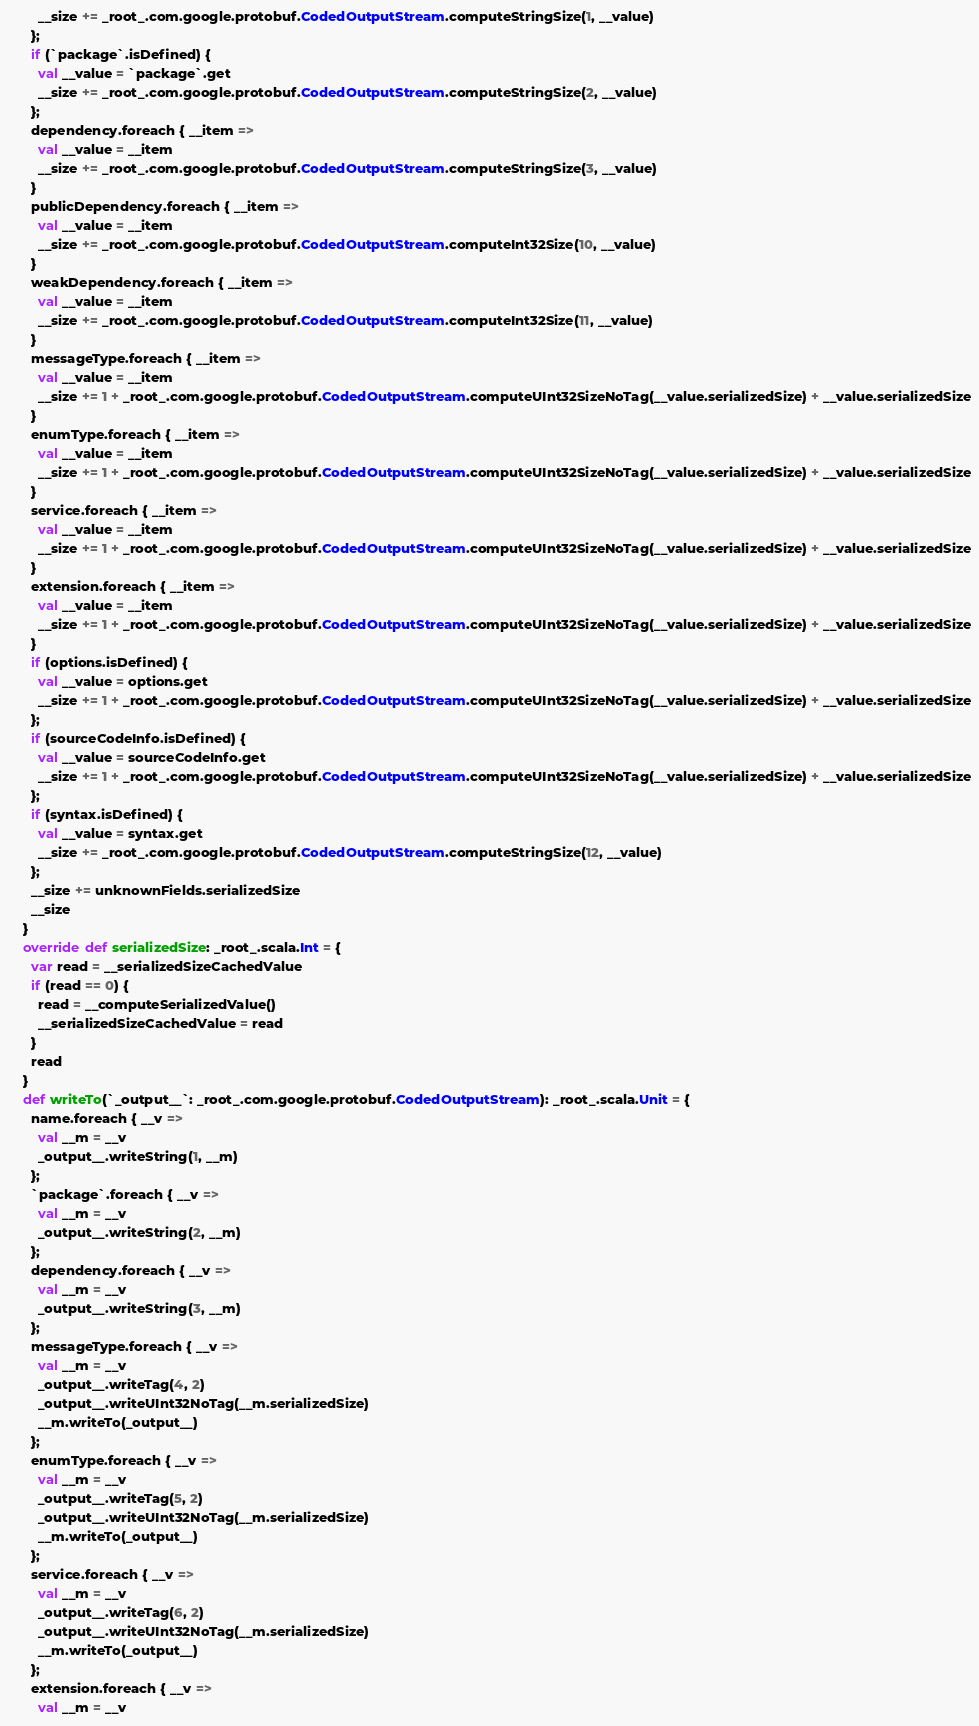Convert code to text. <code><loc_0><loc_0><loc_500><loc_500><_Scala_>        __size += _root_.com.google.protobuf.CodedOutputStream.computeStringSize(1, __value)
      };
      if (`package`.isDefined) {
        val __value = `package`.get
        __size += _root_.com.google.protobuf.CodedOutputStream.computeStringSize(2, __value)
      };
      dependency.foreach { __item =>
        val __value = __item
        __size += _root_.com.google.protobuf.CodedOutputStream.computeStringSize(3, __value)
      }
      publicDependency.foreach { __item =>
        val __value = __item
        __size += _root_.com.google.protobuf.CodedOutputStream.computeInt32Size(10, __value)
      }
      weakDependency.foreach { __item =>
        val __value = __item
        __size += _root_.com.google.protobuf.CodedOutputStream.computeInt32Size(11, __value)
      }
      messageType.foreach { __item =>
        val __value = __item
        __size += 1 + _root_.com.google.protobuf.CodedOutputStream.computeUInt32SizeNoTag(__value.serializedSize) + __value.serializedSize
      }
      enumType.foreach { __item =>
        val __value = __item
        __size += 1 + _root_.com.google.protobuf.CodedOutputStream.computeUInt32SizeNoTag(__value.serializedSize) + __value.serializedSize
      }
      service.foreach { __item =>
        val __value = __item
        __size += 1 + _root_.com.google.protobuf.CodedOutputStream.computeUInt32SizeNoTag(__value.serializedSize) + __value.serializedSize
      }
      extension.foreach { __item =>
        val __value = __item
        __size += 1 + _root_.com.google.protobuf.CodedOutputStream.computeUInt32SizeNoTag(__value.serializedSize) + __value.serializedSize
      }
      if (options.isDefined) {
        val __value = options.get
        __size += 1 + _root_.com.google.protobuf.CodedOutputStream.computeUInt32SizeNoTag(__value.serializedSize) + __value.serializedSize
      };
      if (sourceCodeInfo.isDefined) {
        val __value = sourceCodeInfo.get
        __size += 1 + _root_.com.google.protobuf.CodedOutputStream.computeUInt32SizeNoTag(__value.serializedSize) + __value.serializedSize
      };
      if (syntax.isDefined) {
        val __value = syntax.get
        __size += _root_.com.google.protobuf.CodedOutputStream.computeStringSize(12, __value)
      };
      __size += unknownFields.serializedSize
      __size
    }
    override def serializedSize: _root_.scala.Int = {
      var read = __serializedSizeCachedValue
      if (read == 0) {
        read = __computeSerializedValue()
        __serializedSizeCachedValue = read
      }
      read
    }
    def writeTo(`_output__`: _root_.com.google.protobuf.CodedOutputStream): _root_.scala.Unit = {
      name.foreach { __v =>
        val __m = __v
        _output__.writeString(1, __m)
      };
      `package`.foreach { __v =>
        val __m = __v
        _output__.writeString(2, __m)
      };
      dependency.foreach { __v =>
        val __m = __v
        _output__.writeString(3, __m)
      };
      messageType.foreach { __v =>
        val __m = __v
        _output__.writeTag(4, 2)
        _output__.writeUInt32NoTag(__m.serializedSize)
        __m.writeTo(_output__)
      };
      enumType.foreach { __v =>
        val __m = __v
        _output__.writeTag(5, 2)
        _output__.writeUInt32NoTag(__m.serializedSize)
        __m.writeTo(_output__)
      };
      service.foreach { __v =>
        val __m = __v
        _output__.writeTag(6, 2)
        _output__.writeUInt32NoTag(__m.serializedSize)
        __m.writeTo(_output__)
      };
      extension.foreach { __v =>
        val __m = __v</code> 